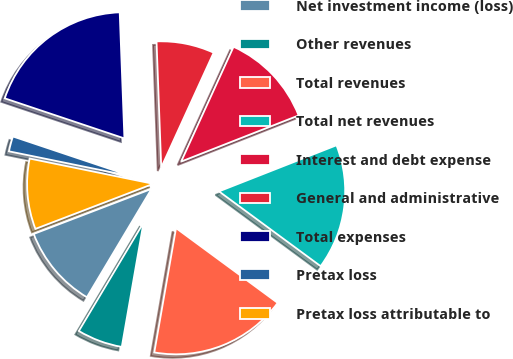Convert chart. <chart><loc_0><loc_0><loc_500><loc_500><pie_chart><fcel>Net investment income (loss)<fcel>Other revenues<fcel>Total revenues<fcel>Total net revenues<fcel>Interest and debt expense<fcel>General and administrative<fcel>Total expenses<fcel>Pretax loss<fcel>Pretax loss attributable to<nl><fcel>10.62%<fcel>5.81%<fcel>17.66%<fcel>16.05%<fcel>12.23%<fcel>7.41%<fcel>19.26%<fcel>1.94%<fcel>9.02%<nl></chart> 